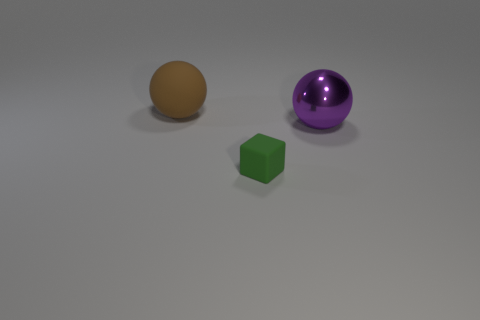Do the large purple sphere and the tiny green cube have the same material?
Give a very brief answer. No. How many rubber things are large cyan blocks or large spheres?
Offer a terse response. 1. What is the shape of the large thing to the right of the brown matte object?
Provide a short and direct response. Sphere. There is a ball that is made of the same material as the tiny block; what is its size?
Provide a succinct answer. Large. What is the shape of the thing that is both behind the green object and to the left of the shiny sphere?
Provide a succinct answer. Sphere. Do the rubber thing left of the green object and the small block have the same color?
Provide a short and direct response. No. There is a large thing that is in front of the big rubber sphere; is it the same shape as the matte thing that is behind the large purple shiny object?
Provide a succinct answer. Yes. What size is the rubber thing that is to the left of the small green matte object?
Keep it short and to the point. Large. How big is the ball that is right of the ball to the left of the tiny green matte block?
Ensure brevity in your answer.  Large. Is the number of cyan metallic cubes greater than the number of tiny green matte objects?
Offer a very short reply. No. 